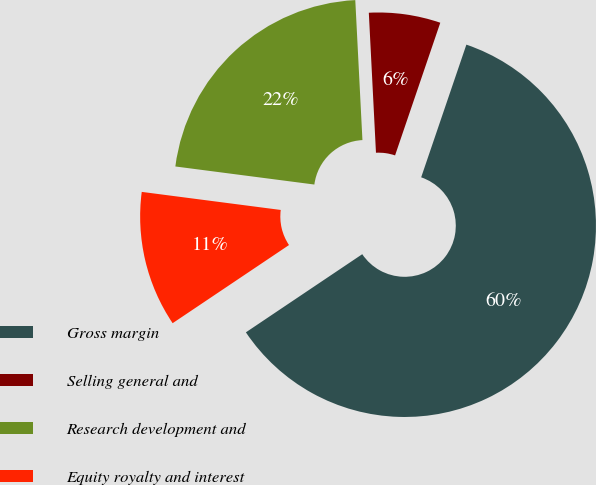<chart> <loc_0><loc_0><loc_500><loc_500><pie_chart><fcel>Gross margin<fcel>Selling general and<fcel>Research development and<fcel>Equity royalty and interest<nl><fcel>60.36%<fcel>6.04%<fcel>22.13%<fcel>11.47%<nl></chart> 